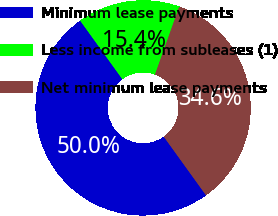<chart> <loc_0><loc_0><loc_500><loc_500><pie_chart><fcel>Minimum lease payments<fcel>Less income from subleases (1)<fcel>Net minimum lease payments<nl><fcel>50.0%<fcel>15.4%<fcel>34.6%<nl></chart> 